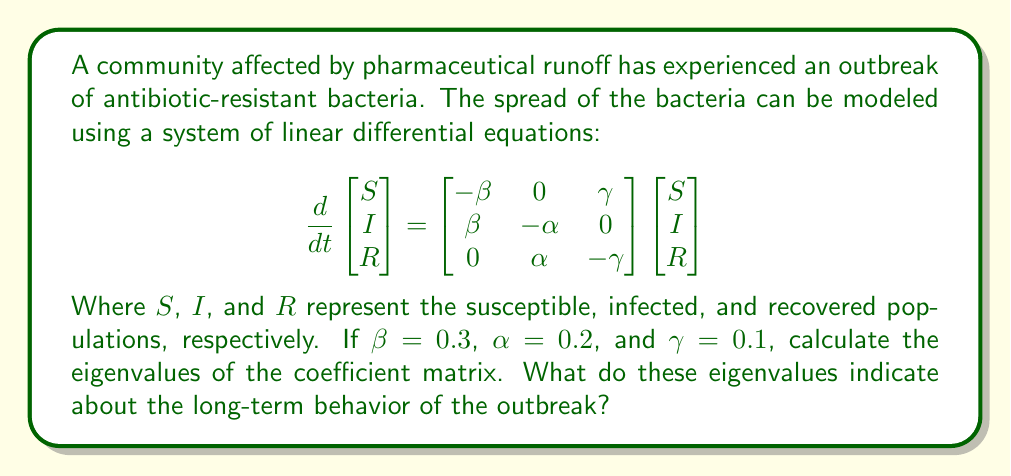Show me your answer to this math problem. To solve this problem, we'll follow these steps:

1) First, let's identify the coefficient matrix:

   $$A = \begin{bmatrix} -0.3 & 0 & 0.1 \\ 0.3 & -0.2 & 0 \\ 0 & 0.2 & -0.1 \end{bmatrix}$$

2) To find the eigenvalues, we need to solve the characteristic equation:

   $$det(A - \lambda I) = 0$$

   Where $I$ is the 3x3 identity matrix and $\lambda$ represents the eigenvalues.

3) Expanding this determinant:

   $$\begin{vmatrix} 
   -0.3 - \lambda & 0 & 0.1 \\
   0.3 & -0.2 - \lambda & 0 \\
   0 & 0.2 & -0.1 - \lambda
   \end{vmatrix} = 0$$

4) This gives us the characteristic polynomial:

   $$(-0.3 - \lambda)(-0.2 - \lambda)(-0.1 - \lambda) - 0.006 = 0$$

5) Expanding:

   $$-\lambda^3 - 0.6\lambda^2 - 0.11\lambda - 0.006 = 0$$

6) This cubic equation can be solved using the cubic formula or numerical methods. The solutions are:

   $$\lambda_1 \approx -0.5424$$
   $$\lambda_2 \approx -0.0288 + 0.0744i$$
   $$\lambda_3 \approx -0.0288 - 0.0744i$$

7) Interpretation: 
   - The negative real eigenvalue ($\lambda_1$) indicates exponential decay in one mode of the system.
   - The complex conjugate pair ($\lambda_2$ and $\lambda_3$) with negative real parts indicates damped oscillations in the other two modes.
   - All eigenvalues having negative real parts suggests that the system is stable and will eventually converge to an equilibrium state.

This means that in the long term, the outbreak will die out, with some oscillations in the population levels before reaching equilibrium.
Answer: Eigenvalues: $\lambda_1 \approx -0.5424$, $\lambda_2 \approx -0.0288 + 0.0744i$, $\lambda_3 \approx -0.0288 - 0.0744i$. Indicates stable system, outbreak will eventually die out with damped oscillations. 